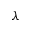<formula> <loc_0><loc_0><loc_500><loc_500>\lambda</formula> 